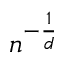Convert formula to latex. <formula><loc_0><loc_0><loc_500><loc_500>n ^ { - \frac { 1 } { d } }</formula> 